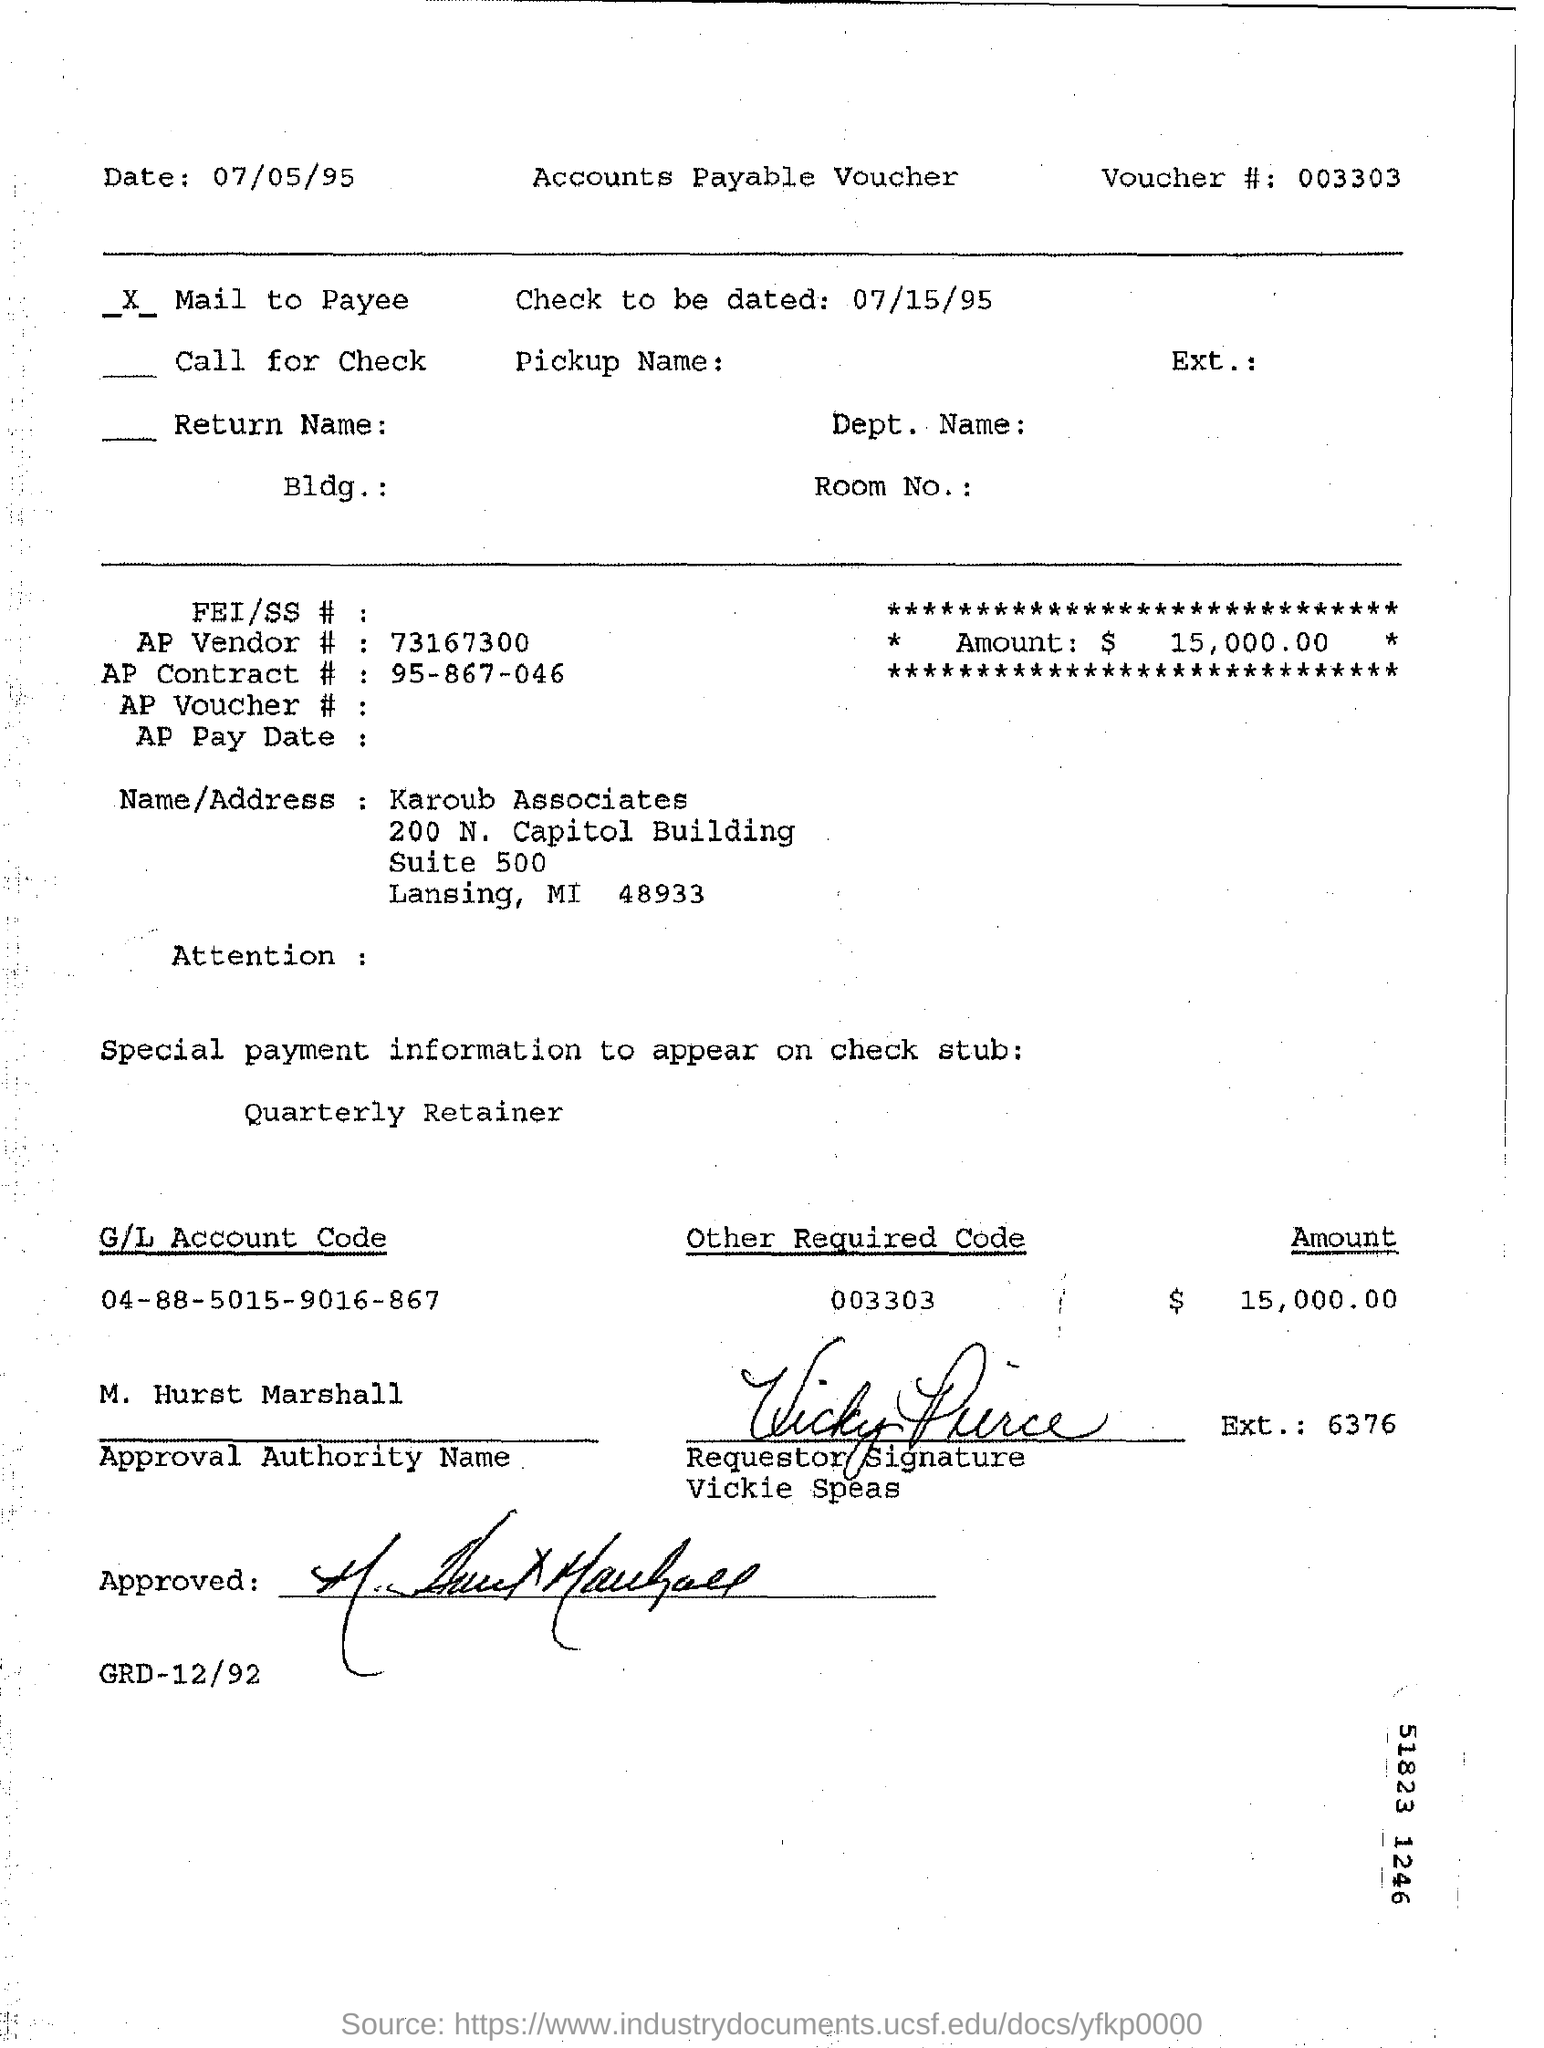Specify some key components in this picture. The G/L Account Code mentioned is 04-88-5015-9016-867. Vickie Speas' signature is followed by an extension number with six digits. The question "What is the 'other required code'?" refers to a specific code that is required in a particular context. The code in question is 003303. The person with the authority to approve is M. Hurst Marshall. Please state the voucher number 003303... 